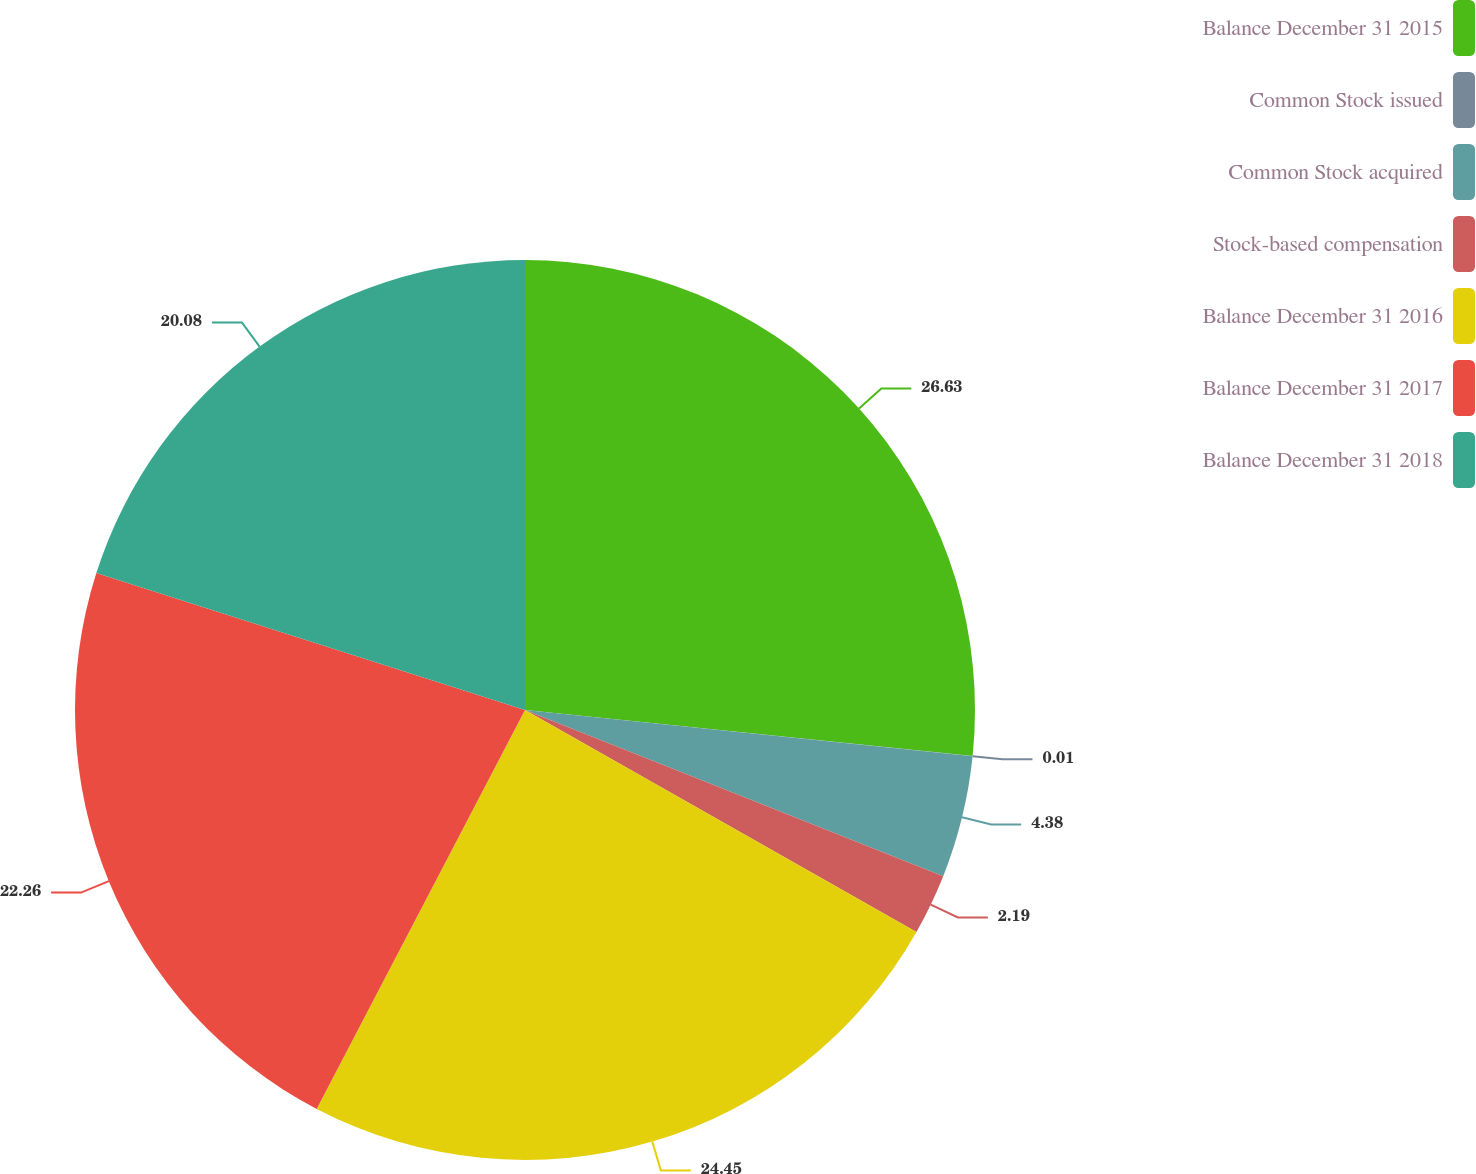<chart> <loc_0><loc_0><loc_500><loc_500><pie_chart><fcel>Balance December 31 2015<fcel>Common Stock issued<fcel>Common Stock acquired<fcel>Stock-based compensation<fcel>Balance December 31 2016<fcel>Balance December 31 2017<fcel>Balance December 31 2018<nl><fcel>26.63%<fcel>0.01%<fcel>4.38%<fcel>2.19%<fcel>24.45%<fcel>22.26%<fcel>20.08%<nl></chart> 